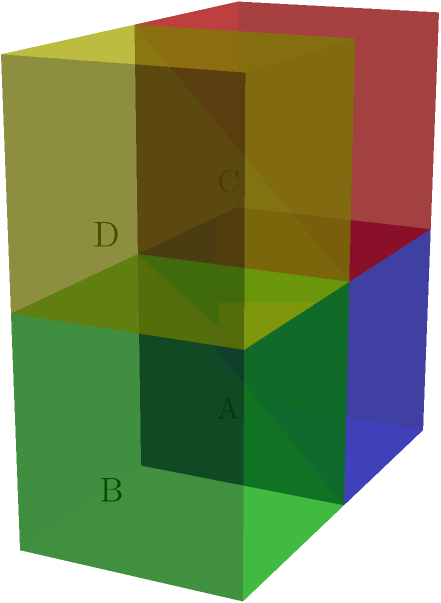In your small warehouse, you have implemented a 3D stacking system as shown in the diagram. Each cube represents a standard storage unit with dimensions 1x1x1 meters. If the total floor space of your warehouse is 2x2 meters, what is the maximum number of these standard storage units you can stack without exceeding a height of 2 meters? To solve this problem, let's follow these steps:

1. Analyze the given information:
   - The warehouse floor space is 2x2 meters
   - Each storage unit is 1x1x1 meters
   - The maximum height is 2 meters

2. Calculate the number of units that can fit on the floor:
   - Floor area = 2 x 2 = 4 square meters
   - Each unit occupies 1 square meter
   - Units on the floor = 4

3. Determine the number of levels that can be stacked:
   - Maximum height = 2 meters
   - Each unit is 1 meter tall
   - Number of levels = 2

4. Calculate the total number of units:
   - Total units = Units on the floor × Number of levels
   - Total units = 4 × 2 = 8

Therefore, you can stack a maximum of 8 standard storage units in your warehouse without exceeding the 2-meter height limit.
Answer: 8 units 